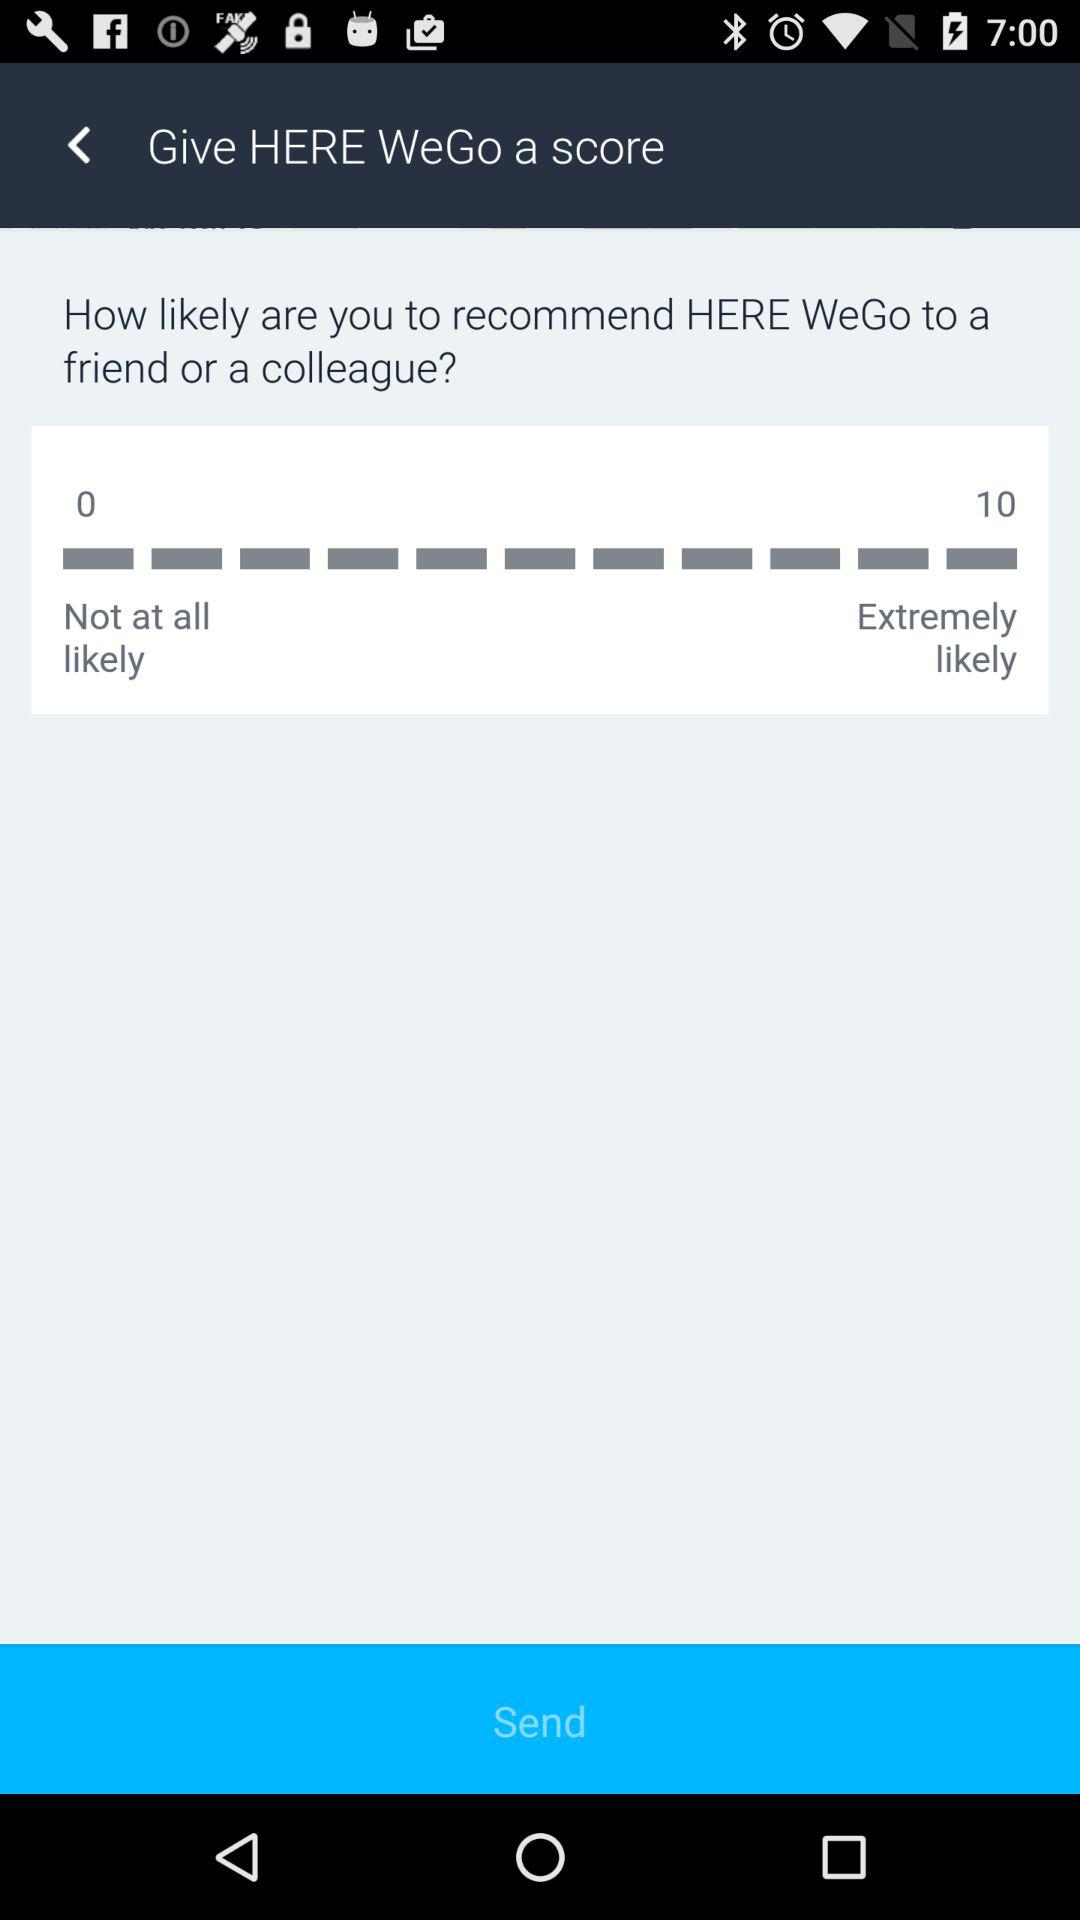What is the difference between the maximum and minimum ratings?
Answer the question using a single word or phrase. 10 